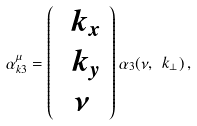Convert formula to latex. <formula><loc_0><loc_0><loc_500><loc_500>\alpha ^ { \mu } _ { k 3 } = \left ( \begin{array} { c } \ k _ { x } \\ \ k _ { y } \\ \nu \end{array} \right ) \alpha _ { 3 } ( \nu , \ k _ { \perp } ) \, ,</formula> 